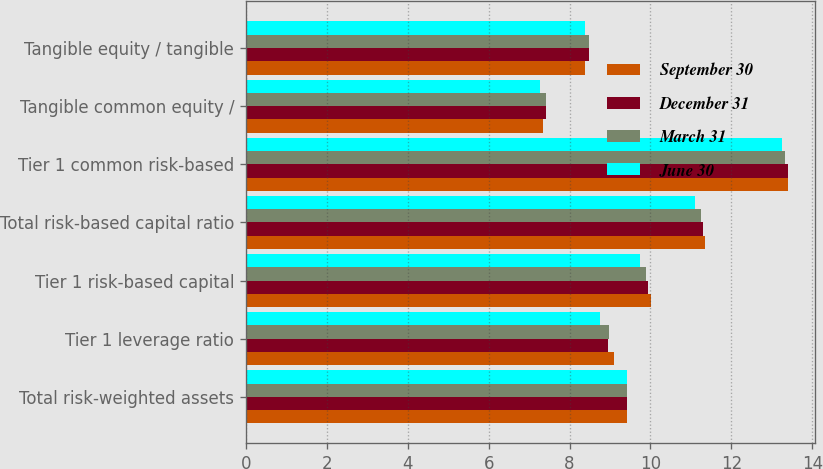Convert chart to OTSL. <chart><loc_0><loc_0><loc_500><loc_500><stacked_bar_chart><ecel><fcel>Total risk-weighted assets<fcel>Tier 1 leverage ratio<fcel>Tier 1 risk-based capital<fcel>Total risk-based capital ratio<fcel>Tier 1 common risk-based<fcel>Tangible common equity /<fcel>Tangible equity / tangible<nl><fcel>September 30<fcel>9.415<fcel>9.09<fcel>10.01<fcel>11.34<fcel>13.39<fcel>7.34<fcel>8.39<nl><fcel>December 31<fcel>9.415<fcel>8.96<fcel>9.94<fcel>11.3<fcel>13.39<fcel>7.42<fcel>8.49<nl><fcel>March 31<fcel>9.415<fcel>8.98<fcel>9.88<fcel>11.24<fcel>13.33<fcel>7.41<fcel>8.49<nl><fcel>June 30<fcel>9.415<fcel>8.76<fcel>9.74<fcel>11.11<fcel>13.26<fcel>7.28<fcel>8.38<nl></chart> 